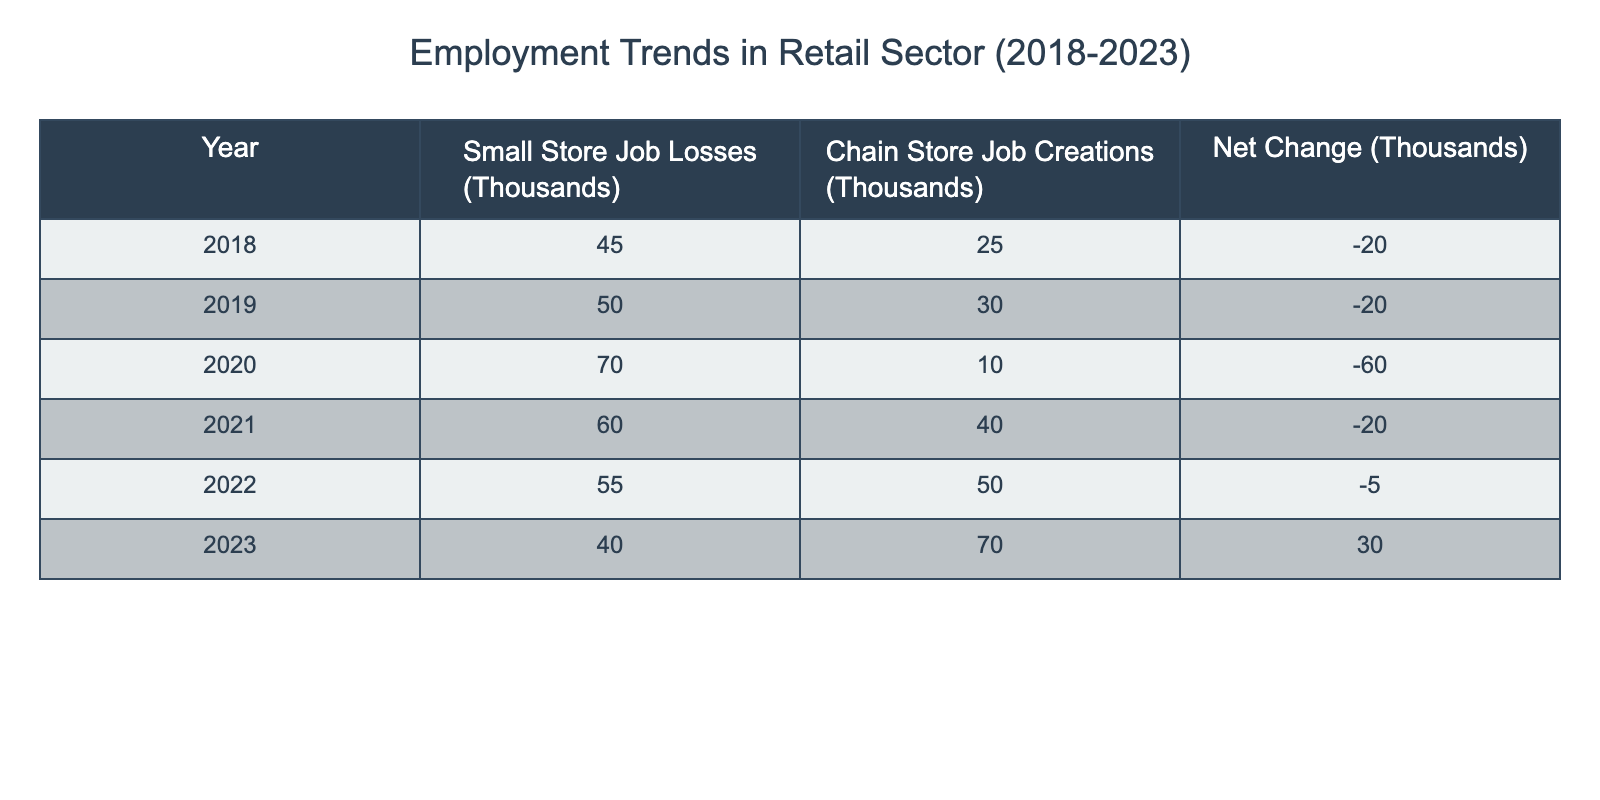What was the total job loss from small stores in 2020? The table indicates that in 2020, small store job losses amounted to 70 thousand.
Answer: 70 thousand What was the net change in employment in the retail sector in 2023? According to the table, the net change in 2023 is recorded as 30 thousand, indicating job creation outpacing losses for that year.
Answer: 30 thousand Which year had the highest job losses for small stores? By reviewing the data presented, 2020 recorded the highest small store job losses with 70 thousand, surpassing losses in other years.
Answer: 2020 What is the difference between small store job losses and chain store job creations in 2021? In 2021, small store job losses were 60 thousand and chain store job creations were 40 thousand. The difference is calculated as 60 - 40 = 20, indicating that losses exceeded job creations by this amount.
Answer: 20 thousand Did chain stores create more jobs than small stores lost in 2022? In 2022, small store job losses were 55 thousand while chain store job creations were 50 thousand. Since 55 is greater than 50, the statement is false.
Answer: No What was the average annual job loss of small stores from 2018 to 2022? To find the average, sum the job losses from 2018 to 2022: 45 + 50 + 70 + 60 + 55 = 280 thousand. There are 5 data points, thus the average is 280 / 5 = 56 thousand.
Answer: 56 thousand What was the trend in job creation for chain stores from 2018 to 2023? Observing the table, chain store job creations started at 25 thousand in 2018, peaked at 70 thousand in 2023, indicating an upward trend over the years.
Answer: Upward trend Was there ever a year where small store job loss exceeded 60 thousand? The data reveals that small store job losses exceeded 60 thousand in 2020 (70 thousand) and 2021 (60 thousand), making the statement true.
Answer: Yes In which year did the retail sector see a net positive change? The table illustrates that 2023 is the only year with a net positive change of 30 thousand, signifying job growth in that year, while all previous years showed net losses.
Answer: 2023 